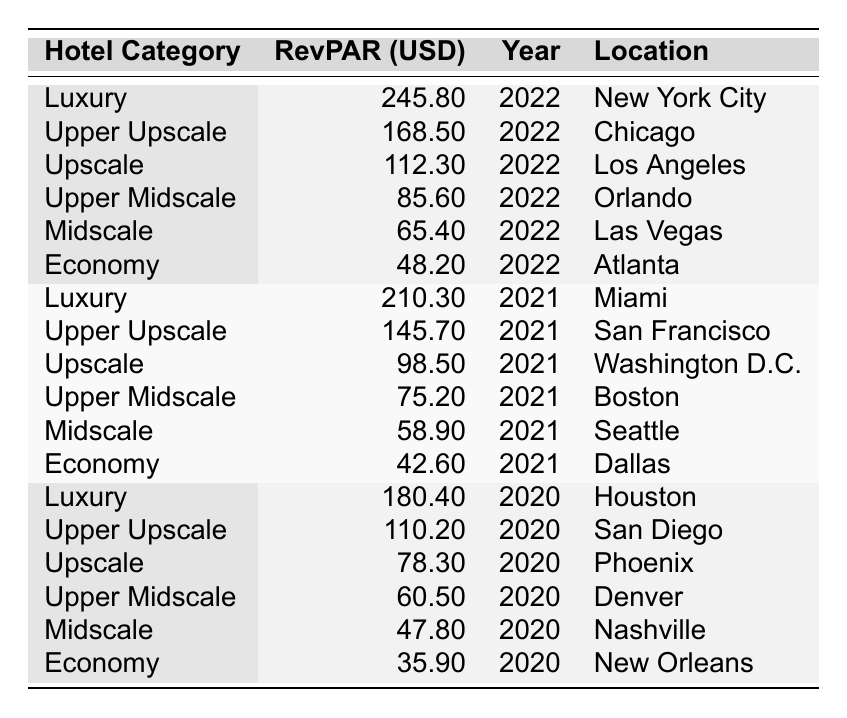What is the RevPAR for Luxury hotels in New York City in 2022? The table shows a row for Luxury hotels in New York City for the year 2022, with a RevPAR value of 245.80 USD.
Answer: 245.80 USD Which hotel category has the highest RevPAR in 2022? By looking at the 2022 data, the Luxury category has the highest RevPAR of 245.80 USD, compared to other categories.
Answer: Luxury What is the difference in RevPAR between Midscale hotels in 2022 and Economy hotels in 2021? The RevPAR for Midscale hotels in 2022 is 65.40 USD, and for Economy hotels in 2021, it is 42.60 USD. The difference is 65.40 - 42.60 = 22.80 USD.
Answer: 22.80 USD Is the RevPAR for Upper Upscale hotels in 2021 higher than that for Upscale hotels in 2020? The RevPAR for Upper Upscale hotels in 2021 is 145.70 USD, while for Upscale hotels in 2020 it is 78.30 USD. Since 145.70 > 78.30, the statement is true.
Answer: Yes What is the average RevPAR for Economy hotels across all years shown? Sum the RevPARs for Economy hotels: 48.20 (2022) + 42.60 (2021) + 35.90 (2020) = 126.70 USD. There are 3 data points, so the average is 126.70 / 3 = 42.23 USD.
Answer: 42.23 USD Which hotel category had the lowest RevPAR in 2020? The table shows that Economy hotels had the lowest RevPAR in 2020 with a value of 35.90 USD compared to other categories for that year.
Answer: Economy What is the RevPAR range for all Upper Midscale hotels from 2020 to 2022? Upper Midscale hotels have a RevPAR of 85.60 USD in 2022, 75.20 USD in 2021, and 60.50 USD in 2020. The range is from 60.50 to 85.60, or 85.60 - 60.50 = 25.10 USD.
Answer: 25.10 USD Is it true that Luxury hotels have consistently high RevPAR over the years shown? Reviewing the data, Luxury hotels have RevPARs of 180.40 (2020), 210.30 (2021), and 245.80 (2022) which consistently shows an increase, confirming this statement is true.
Answer: Yes How many hotel categories have a RevPAR over 100 USD in 2022? In 2022, the categories with RevPARs over 100 USD are Luxury (245.80), Upper Upscale (168.50), and Upscale (112.30). This leads to a total of 3 categories.
Answer: 3 